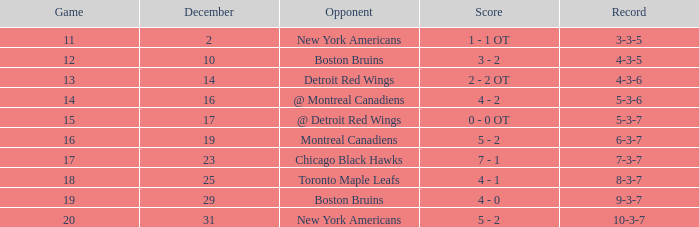Which Game is the highest one that has a Record of 4-3-6? 13.0. 